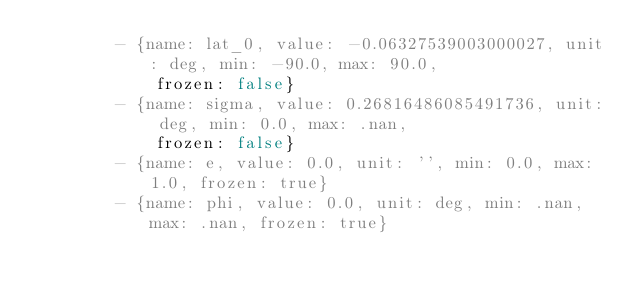<code> <loc_0><loc_0><loc_500><loc_500><_YAML_>        - {name: lat_0, value: -0.06327539003000027, unit: deg, min: -90.0, max: 90.0,
            frozen: false}
        - {name: sigma, value: 0.26816486085491736, unit: deg, min: 0.0, max: .nan,
            frozen: false}
        - {name: e, value: 0.0, unit: '', min: 0.0, max: 1.0, frozen: true}
        - {name: phi, value: 0.0, unit: deg, min: .nan, max: .nan, frozen: true}
</code> 